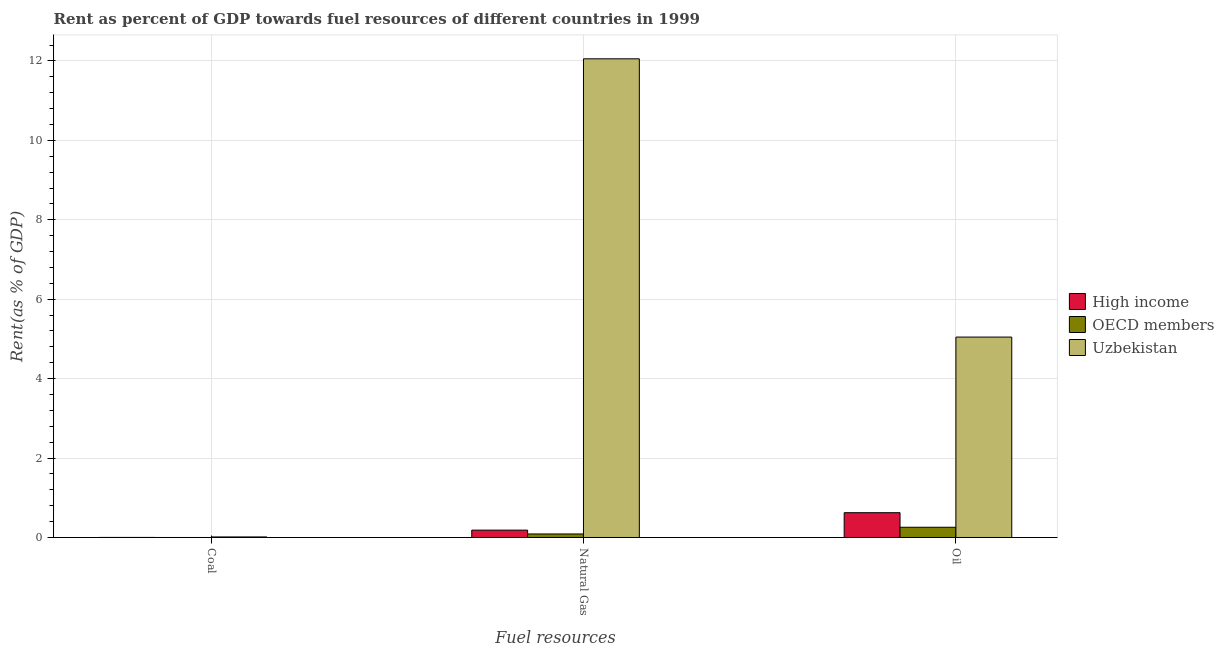Are the number of bars per tick equal to the number of legend labels?
Give a very brief answer. Yes. How many bars are there on the 3rd tick from the left?
Offer a very short reply. 3. How many bars are there on the 3rd tick from the right?
Provide a short and direct response. 3. What is the label of the 3rd group of bars from the left?
Provide a short and direct response. Oil. What is the rent towards coal in Uzbekistan?
Provide a short and direct response. 0.01. Across all countries, what is the maximum rent towards natural gas?
Your answer should be compact. 12.05. Across all countries, what is the minimum rent towards natural gas?
Provide a succinct answer. 0.09. In which country was the rent towards coal maximum?
Your answer should be very brief. Uzbekistan. In which country was the rent towards natural gas minimum?
Your response must be concise. OECD members. What is the total rent towards coal in the graph?
Make the answer very short. 0.02. What is the difference between the rent towards oil in Uzbekistan and that in OECD members?
Offer a terse response. 4.79. What is the difference between the rent towards oil in Uzbekistan and the rent towards natural gas in High income?
Your response must be concise. 4.86. What is the average rent towards coal per country?
Your response must be concise. 0.01. What is the difference between the rent towards coal and rent towards oil in High income?
Give a very brief answer. -0.62. What is the ratio of the rent towards coal in OECD members to that in Uzbekistan?
Keep it short and to the point. 0.01. Is the difference between the rent towards coal in Uzbekistan and High income greater than the difference between the rent towards natural gas in Uzbekistan and High income?
Keep it short and to the point. No. What is the difference between the highest and the second highest rent towards oil?
Ensure brevity in your answer.  4.42. What is the difference between the highest and the lowest rent towards natural gas?
Offer a very short reply. 11.96. In how many countries, is the rent towards natural gas greater than the average rent towards natural gas taken over all countries?
Your response must be concise. 1. Is the sum of the rent towards oil in OECD members and High income greater than the maximum rent towards natural gas across all countries?
Your answer should be very brief. No. What does the 3rd bar from the left in Coal represents?
Offer a very short reply. Uzbekistan. What does the 1st bar from the right in Coal represents?
Provide a short and direct response. Uzbekistan. How many bars are there?
Make the answer very short. 9. What is the difference between two consecutive major ticks on the Y-axis?
Your answer should be compact. 2. Are the values on the major ticks of Y-axis written in scientific E-notation?
Offer a very short reply. No. Does the graph contain grids?
Offer a very short reply. Yes. How many legend labels are there?
Provide a succinct answer. 3. What is the title of the graph?
Provide a succinct answer. Rent as percent of GDP towards fuel resources of different countries in 1999. Does "French Polynesia" appear as one of the legend labels in the graph?
Provide a short and direct response. No. What is the label or title of the X-axis?
Offer a terse response. Fuel resources. What is the label or title of the Y-axis?
Provide a short and direct response. Rent(as % of GDP). What is the Rent(as % of GDP) in High income in Coal?
Make the answer very short. 0. What is the Rent(as % of GDP) in OECD members in Coal?
Ensure brevity in your answer.  7.35477210860239e-5. What is the Rent(as % of GDP) of Uzbekistan in Coal?
Provide a short and direct response. 0.01. What is the Rent(as % of GDP) in High income in Natural Gas?
Provide a succinct answer. 0.19. What is the Rent(as % of GDP) in OECD members in Natural Gas?
Provide a succinct answer. 0.09. What is the Rent(as % of GDP) of Uzbekistan in Natural Gas?
Your answer should be compact. 12.05. What is the Rent(as % of GDP) in High income in Oil?
Ensure brevity in your answer.  0.62. What is the Rent(as % of GDP) in OECD members in Oil?
Offer a very short reply. 0.26. What is the Rent(as % of GDP) in Uzbekistan in Oil?
Offer a terse response. 5.05. Across all Fuel resources, what is the maximum Rent(as % of GDP) in High income?
Ensure brevity in your answer.  0.62. Across all Fuel resources, what is the maximum Rent(as % of GDP) in OECD members?
Provide a succinct answer. 0.26. Across all Fuel resources, what is the maximum Rent(as % of GDP) of Uzbekistan?
Your response must be concise. 12.05. Across all Fuel resources, what is the minimum Rent(as % of GDP) of High income?
Your answer should be compact. 0. Across all Fuel resources, what is the minimum Rent(as % of GDP) in OECD members?
Make the answer very short. 7.35477210860239e-5. Across all Fuel resources, what is the minimum Rent(as % of GDP) of Uzbekistan?
Your answer should be compact. 0.01. What is the total Rent(as % of GDP) in High income in the graph?
Your answer should be very brief. 0.81. What is the total Rent(as % of GDP) of OECD members in the graph?
Your answer should be compact. 0.35. What is the total Rent(as % of GDP) in Uzbekistan in the graph?
Your response must be concise. 17.11. What is the difference between the Rent(as % of GDP) of High income in Coal and that in Natural Gas?
Your answer should be compact. -0.18. What is the difference between the Rent(as % of GDP) of OECD members in Coal and that in Natural Gas?
Your response must be concise. -0.09. What is the difference between the Rent(as % of GDP) of Uzbekistan in Coal and that in Natural Gas?
Provide a short and direct response. -12.04. What is the difference between the Rent(as % of GDP) of High income in Coal and that in Oil?
Provide a succinct answer. -0.62. What is the difference between the Rent(as % of GDP) in OECD members in Coal and that in Oil?
Your answer should be compact. -0.26. What is the difference between the Rent(as % of GDP) in Uzbekistan in Coal and that in Oil?
Offer a terse response. -5.03. What is the difference between the Rent(as % of GDP) of High income in Natural Gas and that in Oil?
Offer a terse response. -0.44. What is the difference between the Rent(as % of GDP) of OECD members in Natural Gas and that in Oil?
Give a very brief answer. -0.17. What is the difference between the Rent(as % of GDP) in Uzbekistan in Natural Gas and that in Oil?
Keep it short and to the point. 7.01. What is the difference between the Rent(as % of GDP) in High income in Coal and the Rent(as % of GDP) in OECD members in Natural Gas?
Ensure brevity in your answer.  -0.09. What is the difference between the Rent(as % of GDP) in High income in Coal and the Rent(as % of GDP) in Uzbekistan in Natural Gas?
Provide a succinct answer. -12.05. What is the difference between the Rent(as % of GDP) of OECD members in Coal and the Rent(as % of GDP) of Uzbekistan in Natural Gas?
Offer a very short reply. -12.05. What is the difference between the Rent(as % of GDP) in High income in Coal and the Rent(as % of GDP) in OECD members in Oil?
Your answer should be compact. -0.26. What is the difference between the Rent(as % of GDP) of High income in Coal and the Rent(as % of GDP) of Uzbekistan in Oil?
Provide a short and direct response. -5.05. What is the difference between the Rent(as % of GDP) of OECD members in Coal and the Rent(as % of GDP) of Uzbekistan in Oil?
Give a very brief answer. -5.05. What is the difference between the Rent(as % of GDP) of High income in Natural Gas and the Rent(as % of GDP) of OECD members in Oil?
Provide a succinct answer. -0.07. What is the difference between the Rent(as % of GDP) in High income in Natural Gas and the Rent(as % of GDP) in Uzbekistan in Oil?
Provide a short and direct response. -4.86. What is the difference between the Rent(as % of GDP) of OECD members in Natural Gas and the Rent(as % of GDP) of Uzbekistan in Oil?
Provide a short and direct response. -4.96. What is the average Rent(as % of GDP) of High income per Fuel resources?
Provide a succinct answer. 0.27. What is the average Rent(as % of GDP) in OECD members per Fuel resources?
Provide a short and direct response. 0.12. What is the average Rent(as % of GDP) of Uzbekistan per Fuel resources?
Make the answer very short. 5.7. What is the difference between the Rent(as % of GDP) in High income and Rent(as % of GDP) in OECD members in Coal?
Your answer should be very brief. 0. What is the difference between the Rent(as % of GDP) of High income and Rent(as % of GDP) of Uzbekistan in Coal?
Ensure brevity in your answer.  -0.01. What is the difference between the Rent(as % of GDP) of OECD members and Rent(as % of GDP) of Uzbekistan in Coal?
Provide a short and direct response. -0.01. What is the difference between the Rent(as % of GDP) in High income and Rent(as % of GDP) in OECD members in Natural Gas?
Offer a terse response. 0.1. What is the difference between the Rent(as % of GDP) of High income and Rent(as % of GDP) of Uzbekistan in Natural Gas?
Make the answer very short. -11.87. What is the difference between the Rent(as % of GDP) of OECD members and Rent(as % of GDP) of Uzbekistan in Natural Gas?
Your answer should be very brief. -11.96. What is the difference between the Rent(as % of GDP) of High income and Rent(as % of GDP) of OECD members in Oil?
Keep it short and to the point. 0.37. What is the difference between the Rent(as % of GDP) of High income and Rent(as % of GDP) of Uzbekistan in Oil?
Your response must be concise. -4.42. What is the difference between the Rent(as % of GDP) in OECD members and Rent(as % of GDP) in Uzbekistan in Oil?
Offer a very short reply. -4.79. What is the ratio of the Rent(as % of GDP) of High income in Coal to that in Natural Gas?
Make the answer very short. 0.01. What is the ratio of the Rent(as % of GDP) in OECD members in Coal to that in Natural Gas?
Your answer should be very brief. 0. What is the ratio of the Rent(as % of GDP) of Uzbekistan in Coal to that in Natural Gas?
Ensure brevity in your answer.  0. What is the ratio of the Rent(as % of GDP) in High income in Coal to that in Oil?
Offer a very short reply. 0. What is the ratio of the Rent(as % of GDP) in OECD members in Coal to that in Oil?
Give a very brief answer. 0. What is the ratio of the Rent(as % of GDP) in Uzbekistan in Coal to that in Oil?
Your response must be concise. 0. What is the ratio of the Rent(as % of GDP) of High income in Natural Gas to that in Oil?
Provide a succinct answer. 0.3. What is the ratio of the Rent(as % of GDP) of OECD members in Natural Gas to that in Oil?
Your answer should be very brief. 0.35. What is the ratio of the Rent(as % of GDP) in Uzbekistan in Natural Gas to that in Oil?
Make the answer very short. 2.39. What is the difference between the highest and the second highest Rent(as % of GDP) in High income?
Your response must be concise. 0.44. What is the difference between the highest and the second highest Rent(as % of GDP) of OECD members?
Provide a succinct answer. 0.17. What is the difference between the highest and the second highest Rent(as % of GDP) of Uzbekistan?
Make the answer very short. 7.01. What is the difference between the highest and the lowest Rent(as % of GDP) of High income?
Your response must be concise. 0.62. What is the difference between the highest and the lowest Rent(as % of GDP) in OECD members?
Provide a succinct answer. 0.26. What is the difference between the highest and the lowest Rent(as % of GDP) in Uzbekistan?
Give a very brief answer. 12.04. 